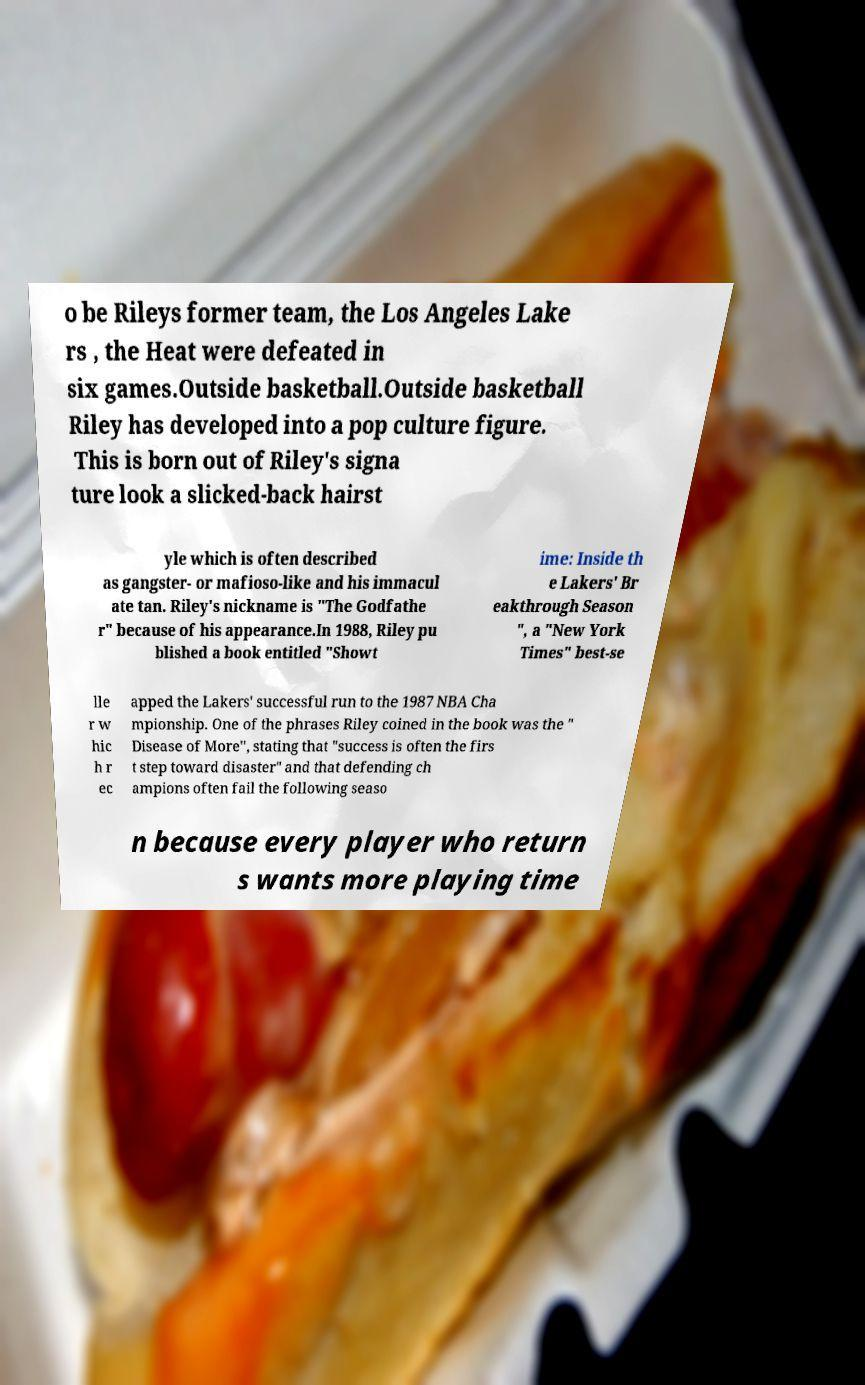Could you extract and type out the text from this image? o be Rileys former team, the Los Angeles Lake rs , the Heat were defeated in six games.Outside basketball.Outside basketball Riley has developed into a pop culture figure. This is born out of Riley's signa ture look a slicked-back hairst yle which is often described as gangster- or mafioso-like and his immacul ate tan. Riley's nickname is "The Godfathe r" because of his appearance.In 1988, Riley pu blished a book entitled "Showt ime: Inside th e Lakers' Br eakthrough Season ", a "New York Times" best-se lle r w hic h r ec apped the Lakers' successful run to the 1987 NBA Cha mpionship. One of the phrases Riley coined in the book was the " Disease of More", stating that "success is often the firs t step toward disaster" and that defending ch ampions often fail the following seaso n because every player who return s wants more playing time 